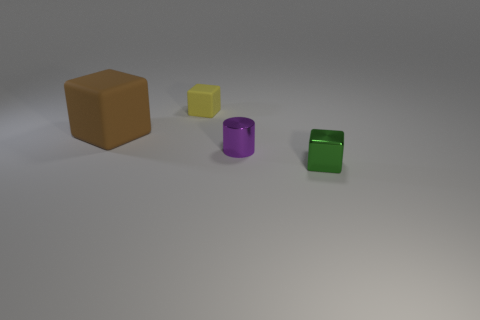How many tiny green things are the same shape as the big object? In the image, there is one small green cube that shares the same shape as the larger brown cube. 